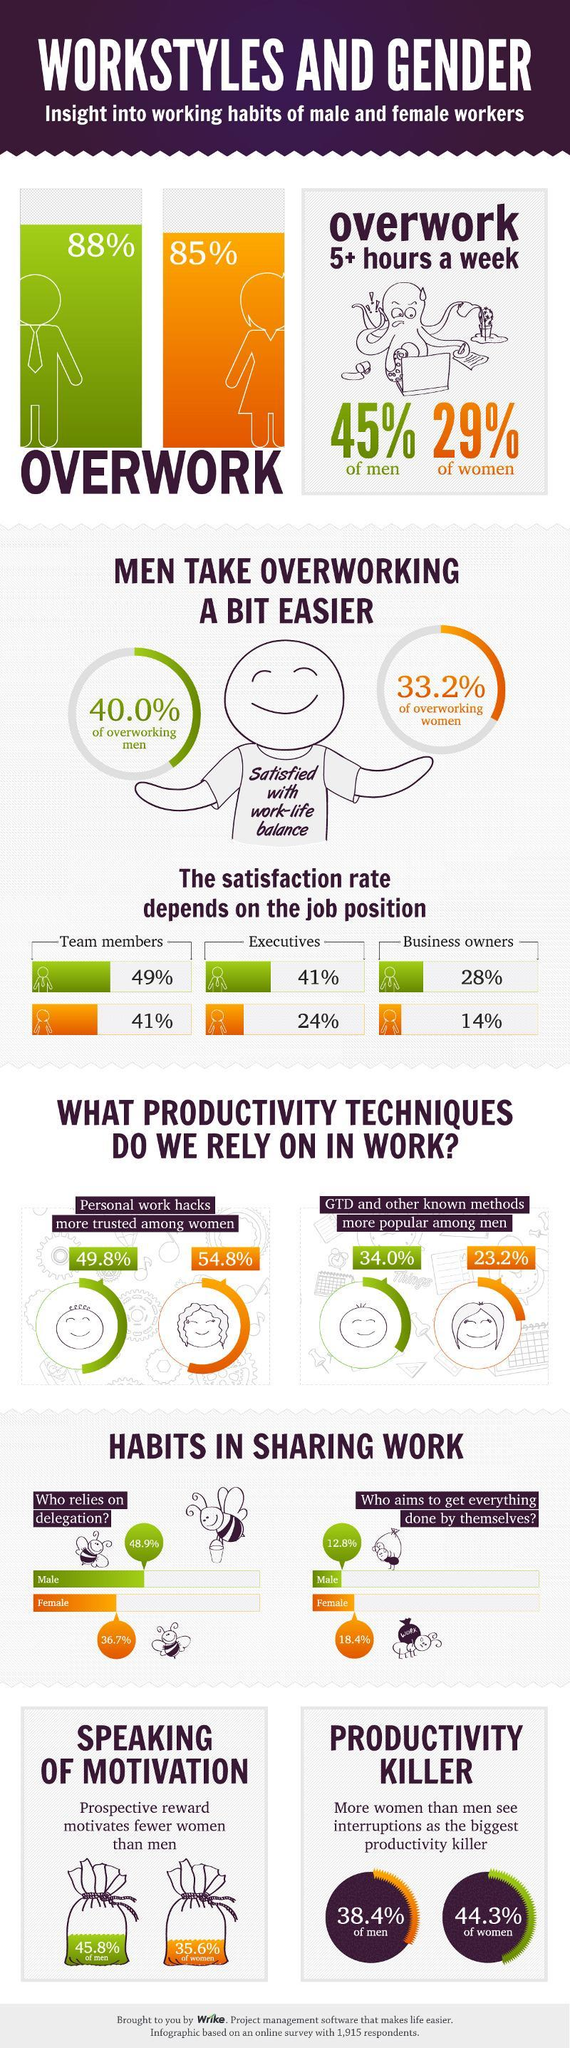What percentage of the overworking women are satisfied with work-life balance?
Answer the question with a short phrase. 33.2% What percent of women were motivated by prospective rewards at work? 35.6% What percent of women trust in personal work hacks? 54.8% What percentage of female team members are satisfied with their job? 41% What percent of men are over working? 88% What is the job satisfaction rate in female business owners? 14% What is the job satisfaction rate in women executives? 24% What percent of the women employees relies on delegation in their workplace? 36.7% What percent of male employees aims to get everything done by themselves at work? 12.8% 